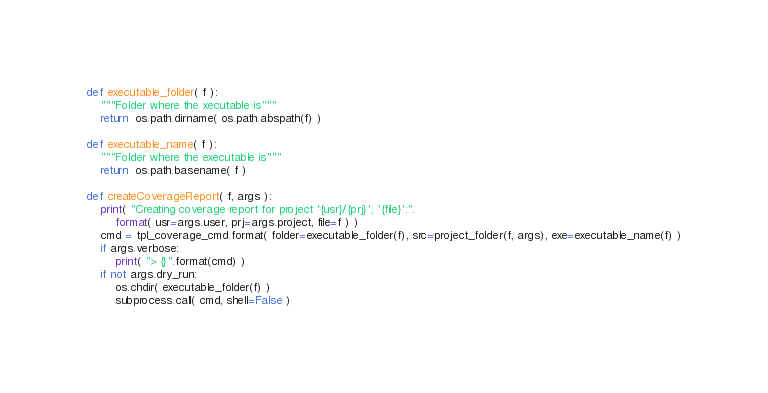Convert code to text. <code><loc_0><loc_0><loc_500><loc_500><_Python_>
def executable_folder( f ):
    """Folder where the xecutable is"""
    return  os.path.dirname( os.path.abspath(f) )

def executable_name( f ):
    """Folder where the executable is"""
    return  os.path.basename( f )

def createCoverageReport( f, args ):
    print( "Creating coverage report for project '{usr}/{prj}', '{file}':".
        format( usr=args.user, prj=args.project, file=f ) )
    cmd = tpl_coverage_cmd.format( folder=executable_folder(f), src=project_folder(f, args), exe=executable_name(f) )
    if args.verbose:
        print( "> {}".format(cmd) )
    if not args.dry_run:
        os.chdir( executable_folder(f) )
        subprocess.call( cmd, shell=False )</code> 